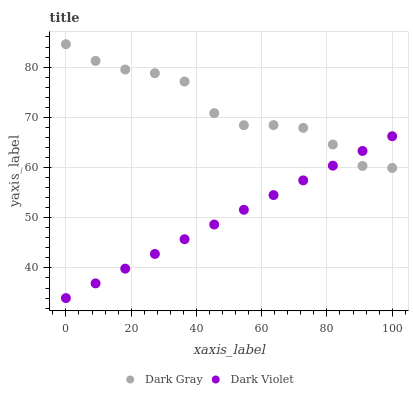Does Dark Violet have the minimum area under the curve?
Answer yes or no. Yes. Does Dark Gray have the maximum area under the curve?
Answer yes or no. Yes. Does Dark Violet have the maximum area under the curve?
Answer yes or no. No. Is Dark Violet the smoothest?
Answer yes or no. Yes. Is Dark Gray the roughest?
Answer yes or no. Yes. Is Dark Violet the roughest?
Answer yes or no. No. Does Dark Violet have the lowest value?
Answer yes or no. Yes. Does Dark Gray have the highest value?
Answer yes or no. Yes. Does Dark Violet have the highest value?
Answer yes or no. No. Does Dark Gray intersect Dark Violet?
Answer yes or no. Yes. Is Dark Gray less than Dark Violet?
Answer yes or no. No. Is Dark Gray greater than Dark Violet?
Answer yes or no. No. 